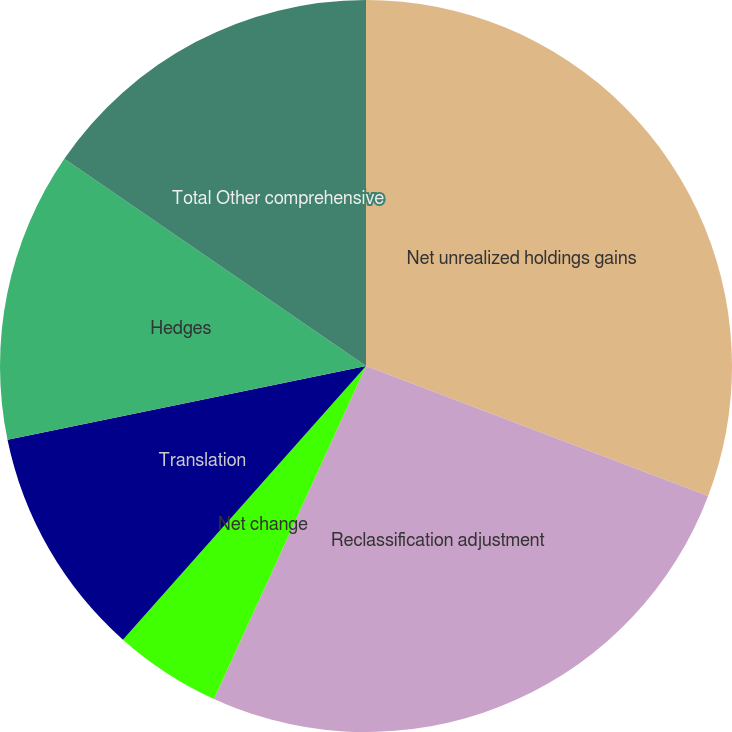Convert chart to OTSL. <chart><loc_0><loc_0><loc_500><loc_500><pie_chart><fcel>Net unrealized holdings gains<fcel>Reclassification adjustment<fcel>Net change<fcel>Translation<fcel>Hedges<fcel>Total Other comprehensive<nl><fcel>30.78%<fcel>26.04%<fcel>4.74%<fcel>10.21%<fcel>12.81%<fcel>15.42%<nl></chart> 